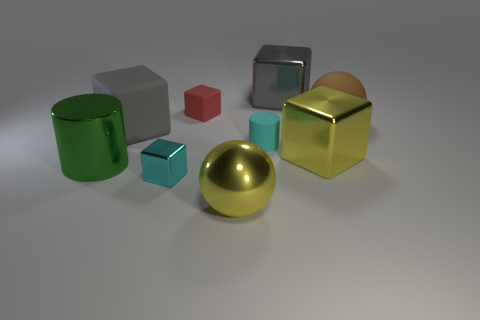Subtract 2 blocks. How many blocks are left? 3 Subtract all yellow blocks. How many blocks are left? 4 Subtract all small red cubes. How many cubes are left? 4 Add 1 tiny cyan matte cylinders. How many objects exist? 10 Subtract all blue cubes. Subtract all purple balls. How many cubes are left? 5 Subtract all blocks. How many objects are left? 4 Add 4 blocks. How many blocks are left? 9 Add 2 tiny red objects. How many tiny red objects exist? 3 Subtract 1 brown spheres. How many objects are left? 8 Subtract all large yellow shiny spheres. Subtract all yellow things. How many objects are left? 6 